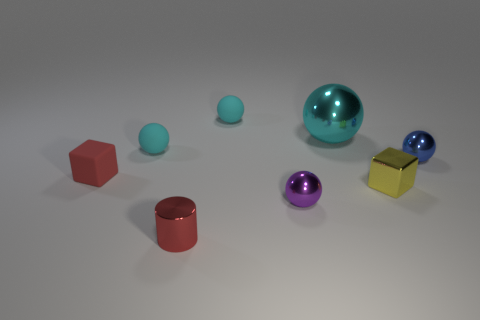Subtract all blue cylinders. How many cyan spheres are left? 3 Subtract all purple balls. How many balls are left? 4 Subtract all small blue metal balls. How many balls are left? 4 Subtract all yellow balls. Subtract all gray cylinders. How many balls are left? 5 Add 1 cyan rubber balls. How many objects exist? 9 Subtract all cubes. How many objects are left? 6 Subtract 0 green cylinders. How many objects are left? 8 Subtract all big brown rubber objects. Subtract all yellow objects. How many objects are left? 7 Add 4 yellow shiny blocks. How many yellow shiny blocks are left? 5 Add 2 large cyan metallic spheres. How many large cyan metallic spheres exist? 3 